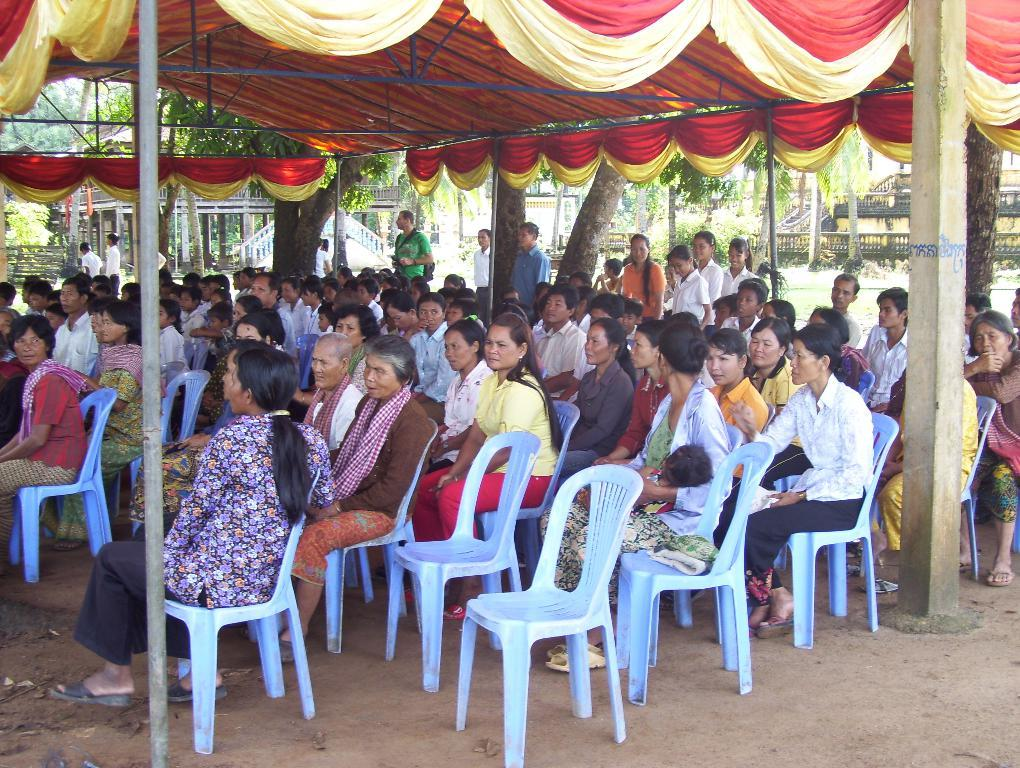How many people are in the image? There is a group of people in the image. What are the people in the image doing? The people are sitting in chairs. What can be seen in the background of the image? There is a tent, a tree, a building, and a pole in the background of the image. Can you tell me what the maid is offering to the people in the image? There is no maid present in the image, so it is not possible to answer that question. 